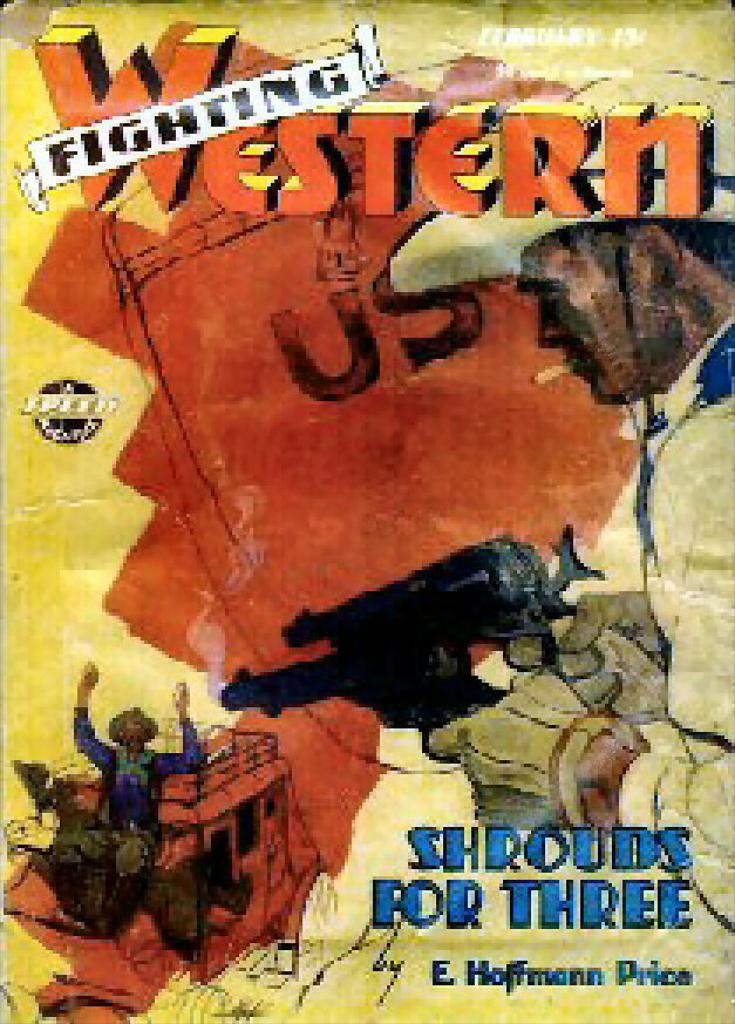<image>
Share a concise interpretation of the image provided. The old cover shown is of a fighting western. 